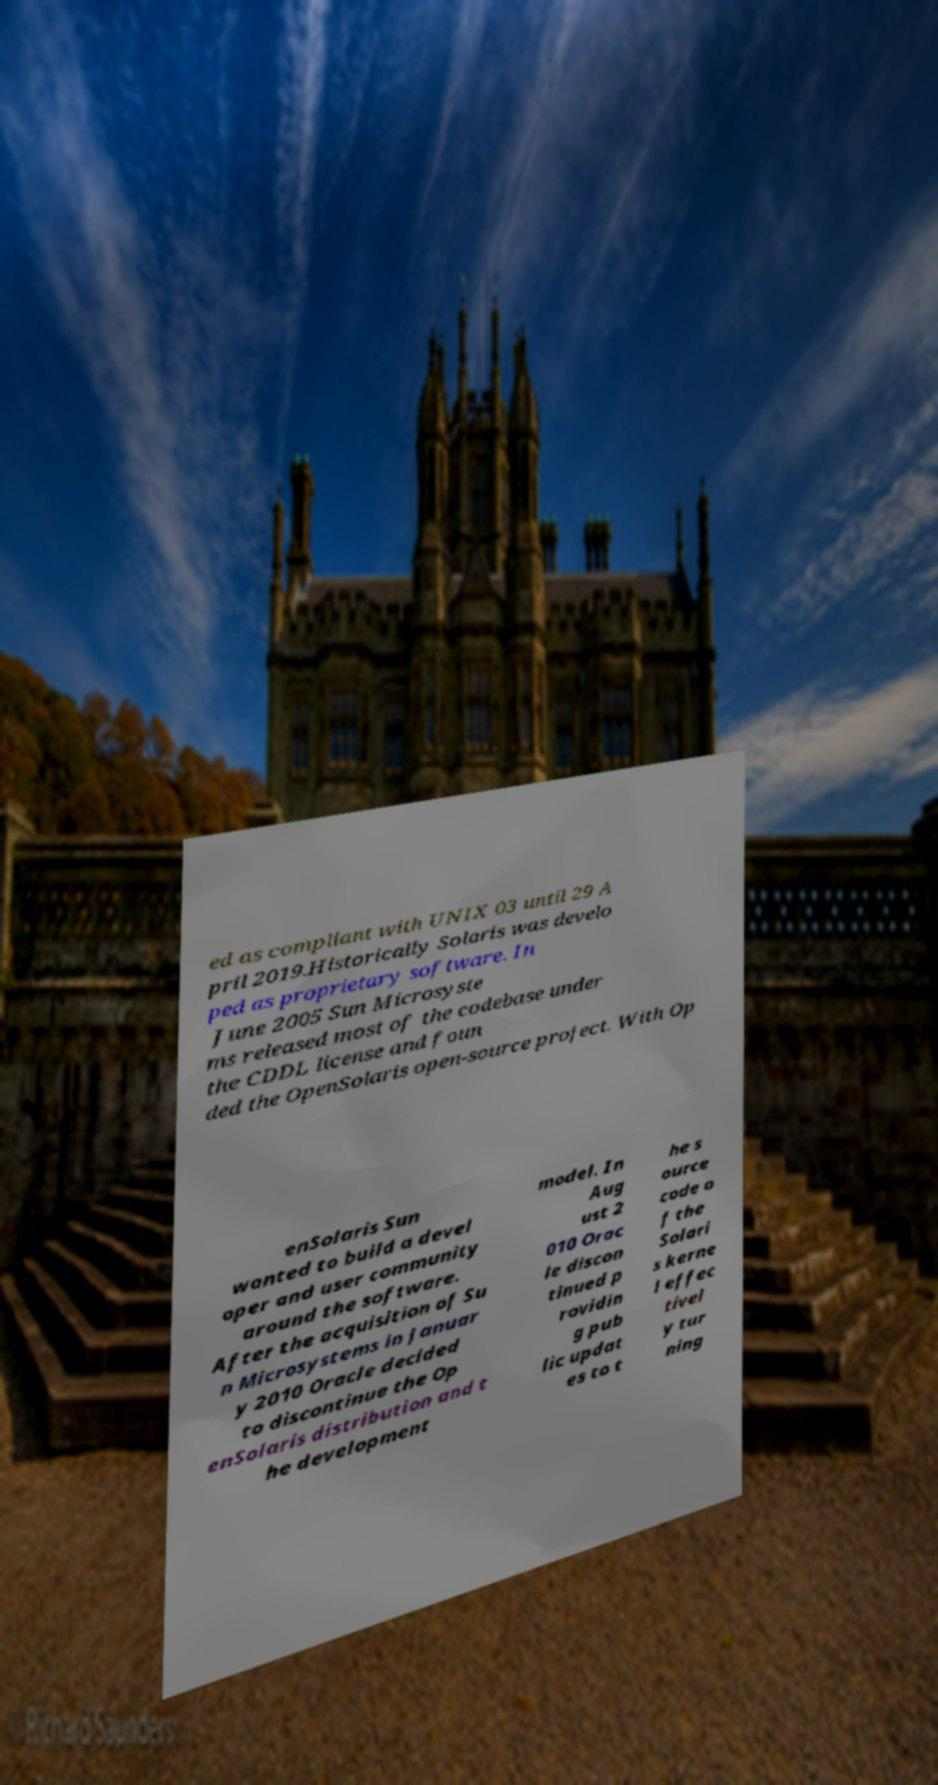Can you accurately transcribe the text from the provided image for me? ed as compliant with UNIX 03 until 29 A pril 2019.Historically Solaris was develo ped as proprietary software. In June 2005 Sun Microsyste ms released most of the codebase under the CDDL license and foun ded the OpenSolaris open-source project. With Op enSolaris Sun wanted to build a devel oper and user community around the software. After the acquisition of Su n Microsystems in Januar y 2010 Oracle decided to discontinue the Op enSolaris distribution and t he development model. In Aug ust 2 010 Orac le discon tinued p rovidin g pub lic updat es to t he s ource code o f the Solari s kerne l effec tivel y tur ning 